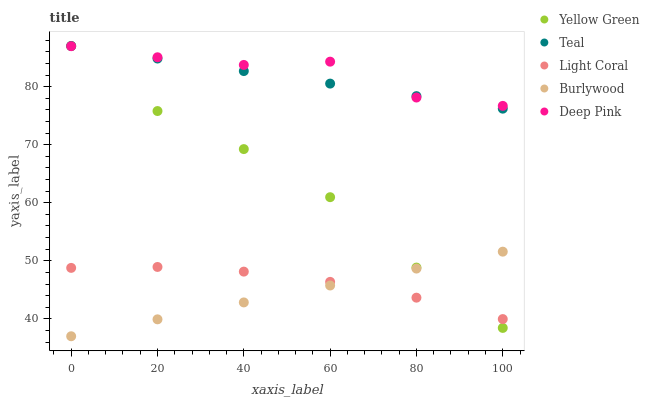Does Burlywood have the minimum area under the curve?
Answer yes or no. Yes. Does Deep Pink have the maximum area under the curve?
Answer yes or no. Yes. Does Deep Pink have the minimum area under the curve?
Answer yes or no. No. Does Burlywood have the maximum area under the curve?
Answer yes or no. No. Is Burlywood the smoothest?
Answer yes or no. Yes. Is Deep Pink the roughest?
Answer yes or no. Yes. Is Deep Pink the smoothest?
Answer yes or no. No. Is Burlywood the roughest?
Answer yes or no. No. Does Burlywood have the lowest value?
Answer yes or no. Yes. Does Deep Pink have the lowest value?
Answer yes or no. No. Does Teal have the highest value?
Answer yes or no. Yes. Does Burlywood have the highest value?
Answer yes or no. No. Is Light Coral less than Teal?
Answer yes or no. Yes. Is Teal greater than Light Coral?
Answer yes or no. Yes. Does Light Coral intersect Yellow Green?
Answer yes or no. Yes. Is Light Coral less than Yellow Green?
Answer yes or no. No. Is Light Coral greater than Yellow Green?
Answer yes or no. No. Does Light Coral intersect Teal?
Answer yes or no. No. 